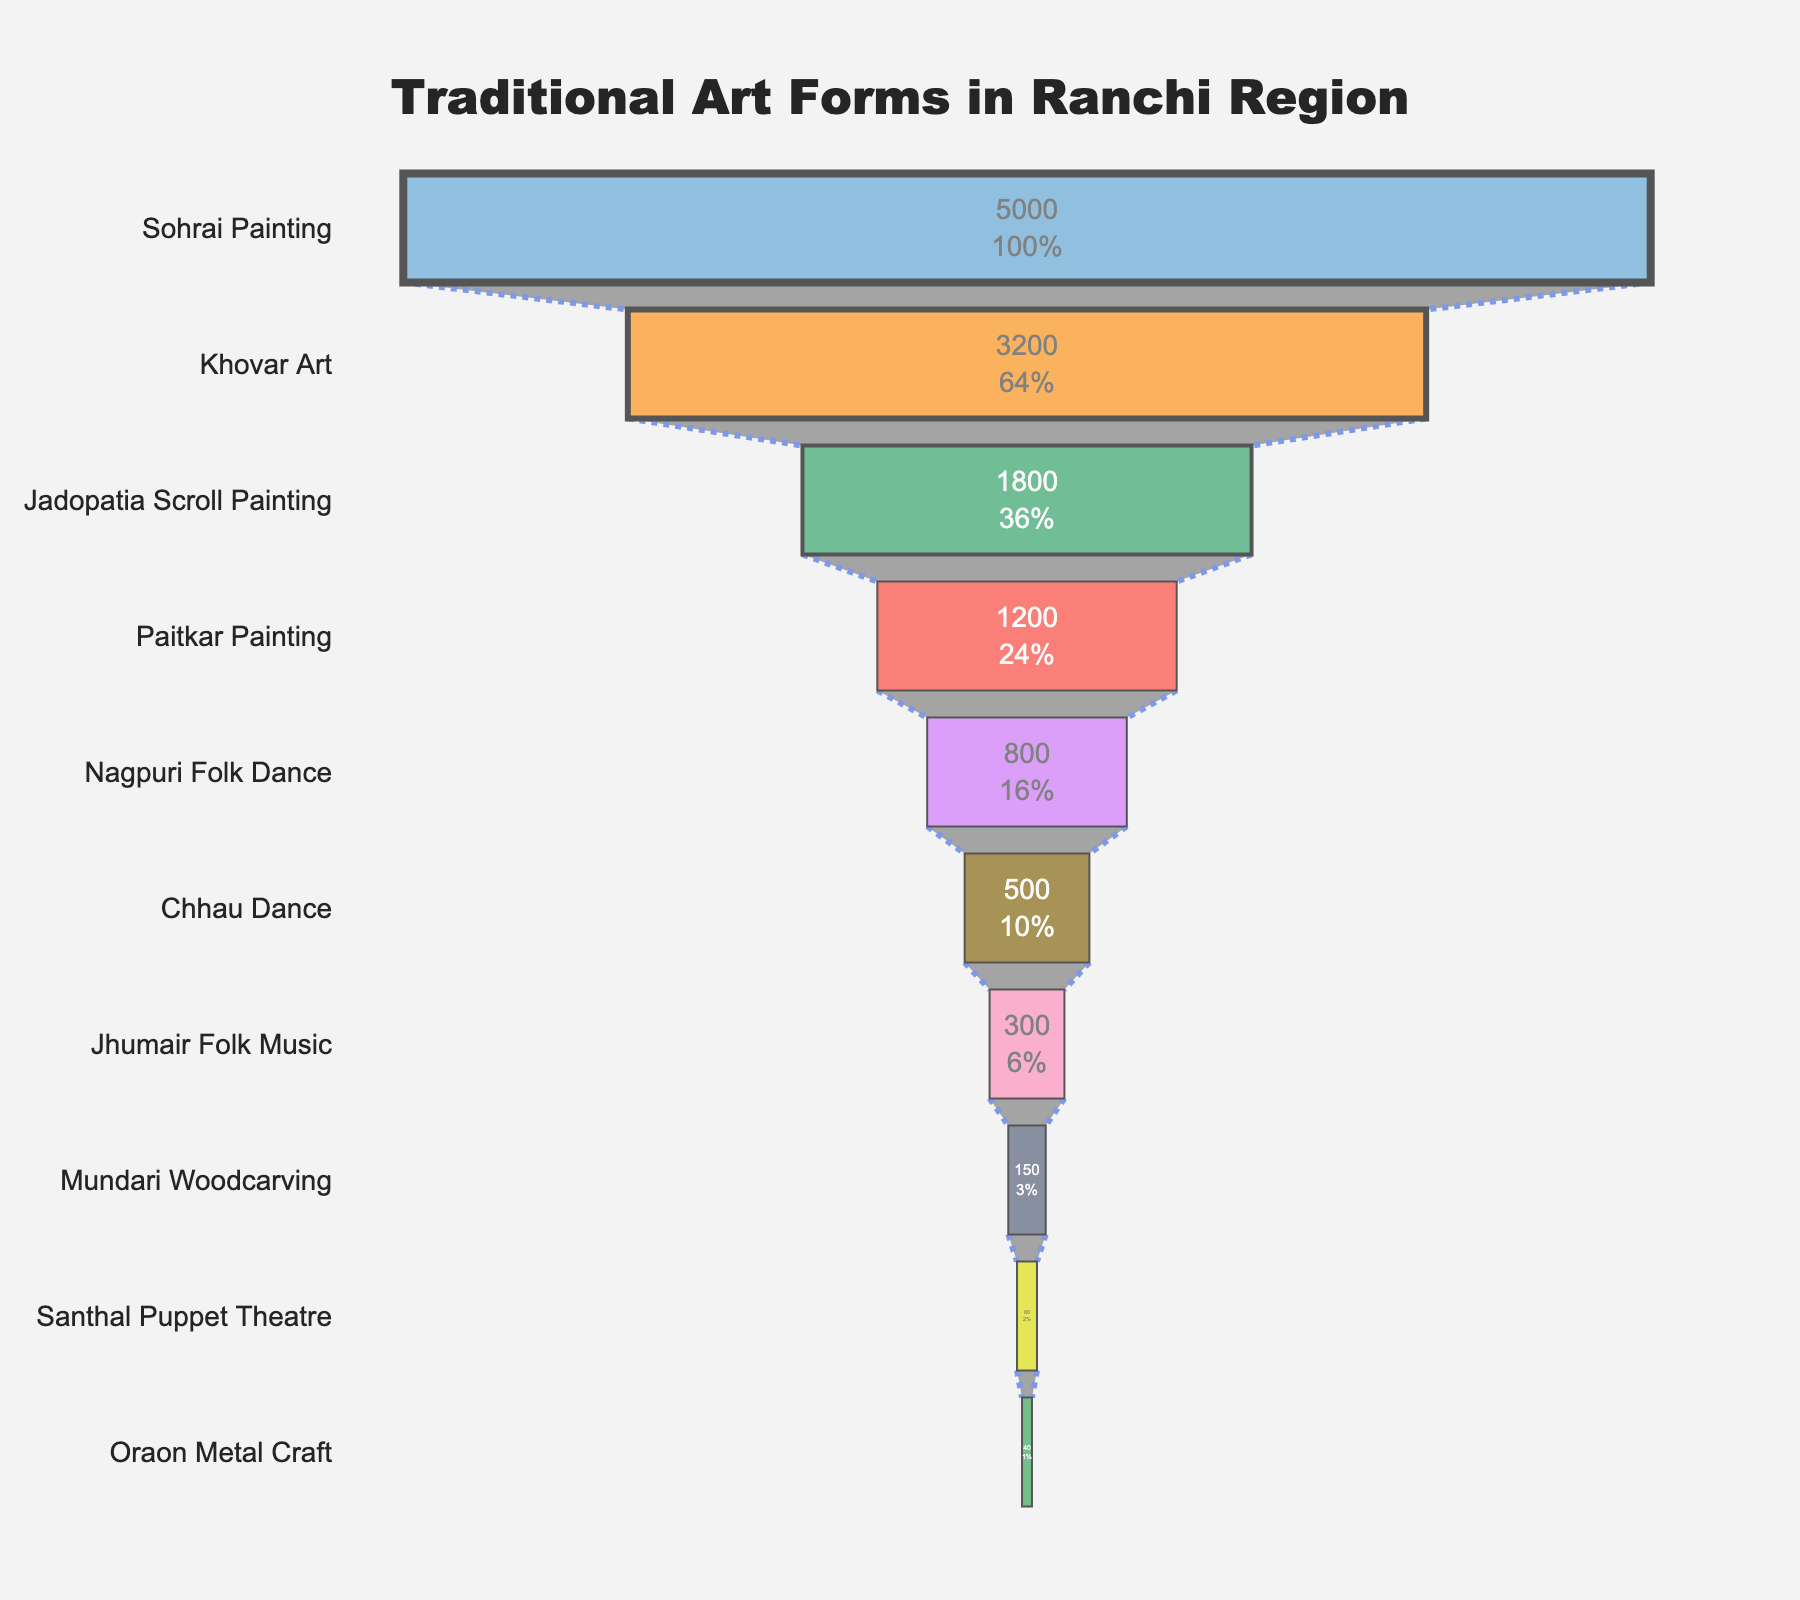What is the most practiced traditional art form in the Ranchi region? The most practiced traditional art form is the one with the highest number of practitioners shown at the top of the funnel chart, which is Sohrai Painting.
Answer: Sohrai Painting How many more practitioners does Sohrai Painting have compared to Oraon Metal Craft? Sohrai Painting has 5000 practitioners while Oraon Metal Craft has 40. Subtracting the two numbers: 5000 - 40 = 4960
Answer: 4960 What percentage of the total practitioners does Khovar Art represent? First, sum up all practitioners (5000 + 3200 + 1800 + 1200 + 800 + 500 + 300 + 150 + 80 + 40 = 12970). Then, divide the number of Khovar Art practitioners by the total and multiply by 100: (3200 / 12970) * 100 ≈ 24.67%
Answer: 24.67% Which art form is practiced by 800 practitioners, and where is it located in the funnel chart? The art form with 800 practitioners is Nagpuri Folk Dance. It is located fifth from the top in the funnel chart.
Answer: Nagpuri Folk Dance; fifth from the top Compare the number of practitioners of Chhau Dance and Jhumair Folk Music. Which one is greater and by how much? Chhau Dance has 500 practitioners, and Jhumair Folk Music has 300 practitioners. Subtract Jhumair Folk Music practitioners from Chhau Dance practitioners: 500 - 300 = 200. Chhau Dance has more practitioners.
Answer: Chhau Dance; by 200 If you combine the practitioners of Paitkar Painting and Mundari Woodcarving, do they reach or exceed the number of Khovar Art practitioners? Paitkar Painting has 1200 practitioners, and Mundari Woodcarving has 150 practitioners. Together they have 1350 practitioners. Khovar Art has 3200 practitioners, which is more than the combined total of Paitkar Painting and Mundari Woodcarving.
Answer: No What is the least practiced art form in the Ranchi region and how many practitioners does it have? The least practiced art form is the one at the bottom of the funnel chart, which is Oraon Metal Craft with 40 practitioners.
Answer: Oraon Metal Craft; 40 Calculate the approximate percentage of practitioners involved in Chhau Dance out of the total number of practitioners. The total number of practitioners is 12970. Chhau Dance has 500 practitioners. (500 / 12970) * 100 ≈ 3.85%
Answer: 3.85% Which traditional art forms have fewer than 100 practitioners? The art forms with fewer than 100 practitioners, located at the bottom of the funnel chart, are Santhal Puppet Theatre (80) and Oraon Metal Craft (40).
Answer: Santhal Puppet Theatre, Oraon Metal Craft Is the number of Sohrai Painting practitioners greater than the combined total of all other art forms? Sohrai Painting has 5000 practitioners. The combined total for all other art forms is 12970 - 5000 = 7970. Sohrai Painting alone does not surpass the combined total of the other art forms.
Answer: No 